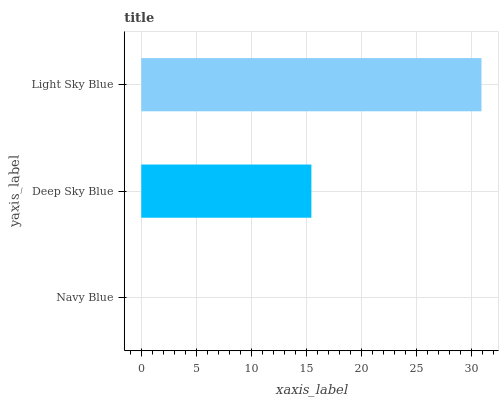Is Navy Blue the minimum?
Answer yes or no. Yes. Is Light Sky Blue the maximum?
Answer yes or no. Yes. Is Deep Sky Blue the minimum?
Answer yes or no. No. Is Deep Sky Blue the maximum?
Answer yes or no. No. Is Deep Sky Blue greater than Navy Blue?
Answer yes or no. Yes. Is Navy Blue less than Deep Sky Blue?
Answer yes or no. Yes. Is Navy Blue greater than Deep Sky Blue?
Answer yes or no. No. Is Deep Sky Blue less than Navy Blue?
Answer yes or no. No. Is Deep Sky Blue the high median?
Answer yes or no. Yes. Is Deep Sky Blue the low median?
Answer yes or no. Yes. Is Light Sky Blue the high median?
Answer yes or no. No. Is Navy Blue the low median?
Answer yes or no. No. 